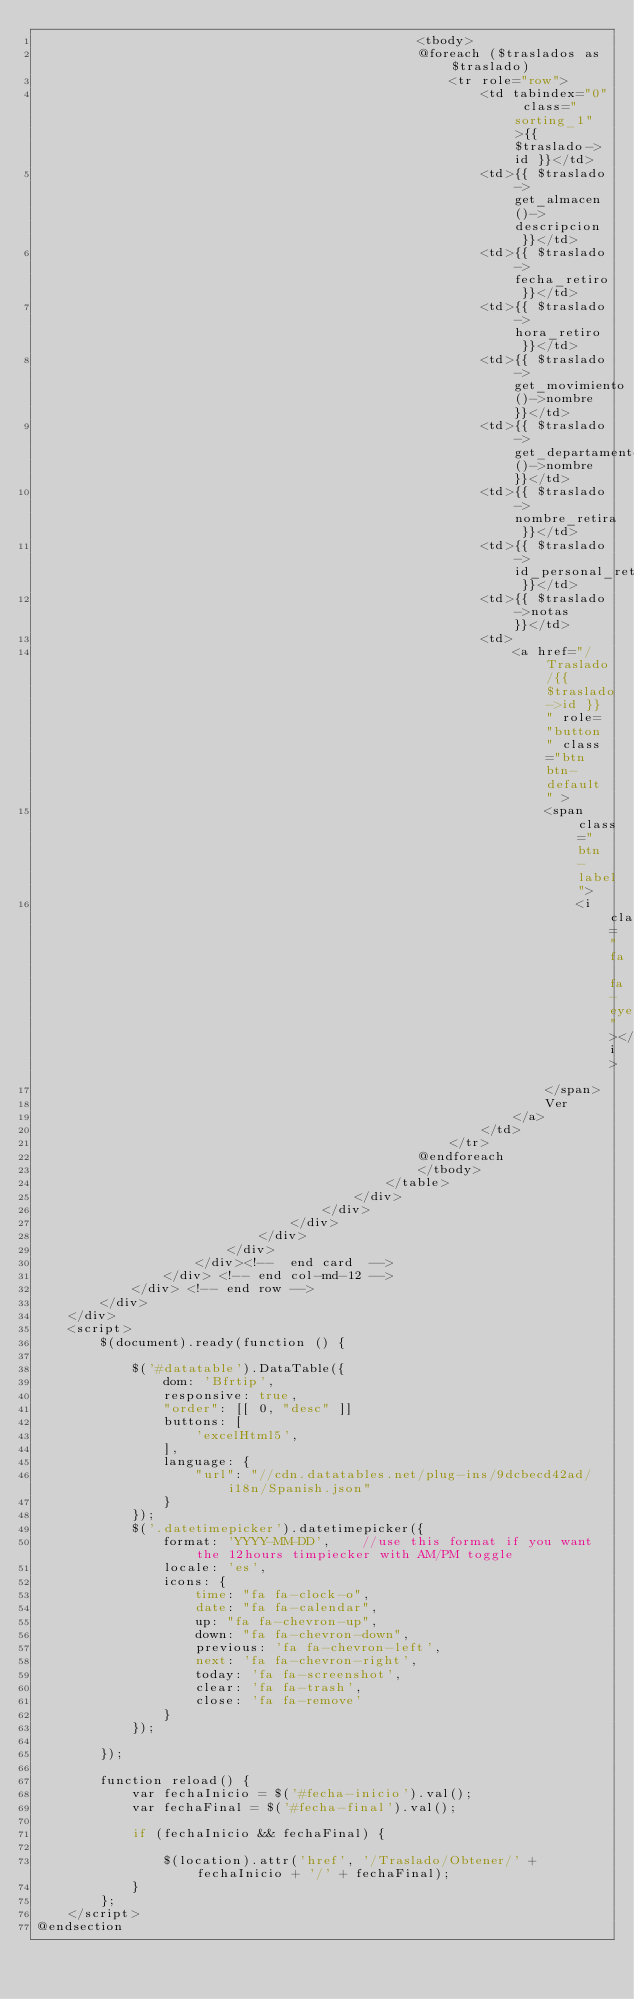<code> <loc_0><loc_0><loc_500><loc_500><_PHP_>                                                <tbody>
                                                @foreach ($traslados as $traslado)
                                                    <tr role="row">
                                                        <td tabindex="0" class="sorting_1">{{ $traslado->id }}</td>
                                                        <td>{{ $traslado->get_almacen()->descripcion }}</td>
                                                        <td>{{ $traslado->fecha_retiro }}</td>
                                                        <td>{{ $traslado->hora_retiro }}</td>
                                                        <td>{{ $traslado->get_movimiento()->nombre }}</td>
                                                        <td>{{ $traslado->get_departamento()->nombre }}</td>
                                                        <td>{{ $traslado->nombre_retira }}</td>
                                                        <td>{{ $traslado->id_personal_retira }}</td>
                                                        <td>{{ $traslado->notas }}</td>
                                                        <td>
                                                            <a href="/Traslado/{{ $traslado->id }}" role="button" class="btn btn-default" >
                                                                <span class="btn-label">
                                                                    <i class="fa fa-eye"></i>
                                                                </span>
                                                                Ver
                                                            </a>
                                                        </td>
                                                    </tr>
                                                @endforeach
                                                </tbody>
                                            </table>
                                        </div>
                                    </div>
                                </div>
                            </div>
                        </div>
                    </div><!--  end card  -->
                </div> <!-- end col-md-12 -->
            </div> <!-- end row -->
        </div>
    </div>
    <script>
        $(document).ready(function () {

            $('#datatable').DataTable({
                dom: 'Bfrtip',
                responsive: true,
                "order": [[ 0, "desc" ]]
                buttons: [
                    'excelHtml5',
                ],
                language: {
                    "url": "//cdn.datatables.net/plug-ins/9dcbecd42ad/i18n/Spanish.json"
                }
            });
            $('.datetimepicker').datetimepicker({
                format: 'YYYY-MM-DD',    //use this format if you want the 12hours timpiecker with AM/PM toggle
                locale: 'es',
                icons: {
                    time: "fa fa-clock-o",
                    date: "fa fa-calendar",
                    up: "fa fa-chevron-up",
                    down: "fa fa-chevron-down",
                    previous: 'fa fa-chevron-left',
                    next: 'fa fa-chevron-right',
                    today: 'fa fa-screenshot',
                    clear: 'fa fa-trash',
                    close: 'fa fa-remove'
                }
            });

        });

        function reload() {
            var fechaInicio = $('#fecha-inicio').val();
            var fechaFinal = $('#fecha-final').val();

            if (fechaInicio && fechaFinal) {

                $(location).attr('href', '/Traslado/Obtener/' + fechaInicio + '/' + fechaFinal);
            }
        };
    </script>
@endsection</code> 